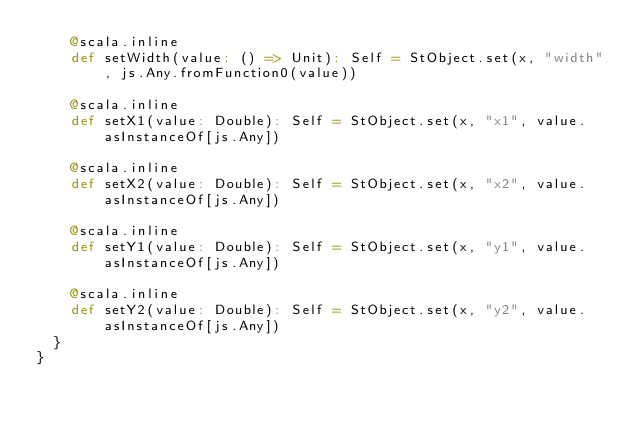<code> <loc_0><loc_0><loc_500><loc_500><_Scala_>    @scala.inline
    def setWidth(value: () => Unit): Self = StObject.set(x, "width", js.Any.fromFunction0(value))
    
    @scala.inline
    def setX1(value: Double): Self = StObject.set(x, "x1", value.asInstanceOf[js.Any])
    
    @scala.inline
    def setX2(value: Double): Self = StObject.set(x, "x2", value.asInstanceOf[js.Any])
    
    @scala.inline
    def setY1(value: Double): Self = StObject.set(x, "y1", value.asInstanceOf[js.Any])
    
    @scala.inline
    def setY2(value: Double): Self = StObject.set(x, "y2", value.asInstanceOf[js.Any])
  }
}
</code> 